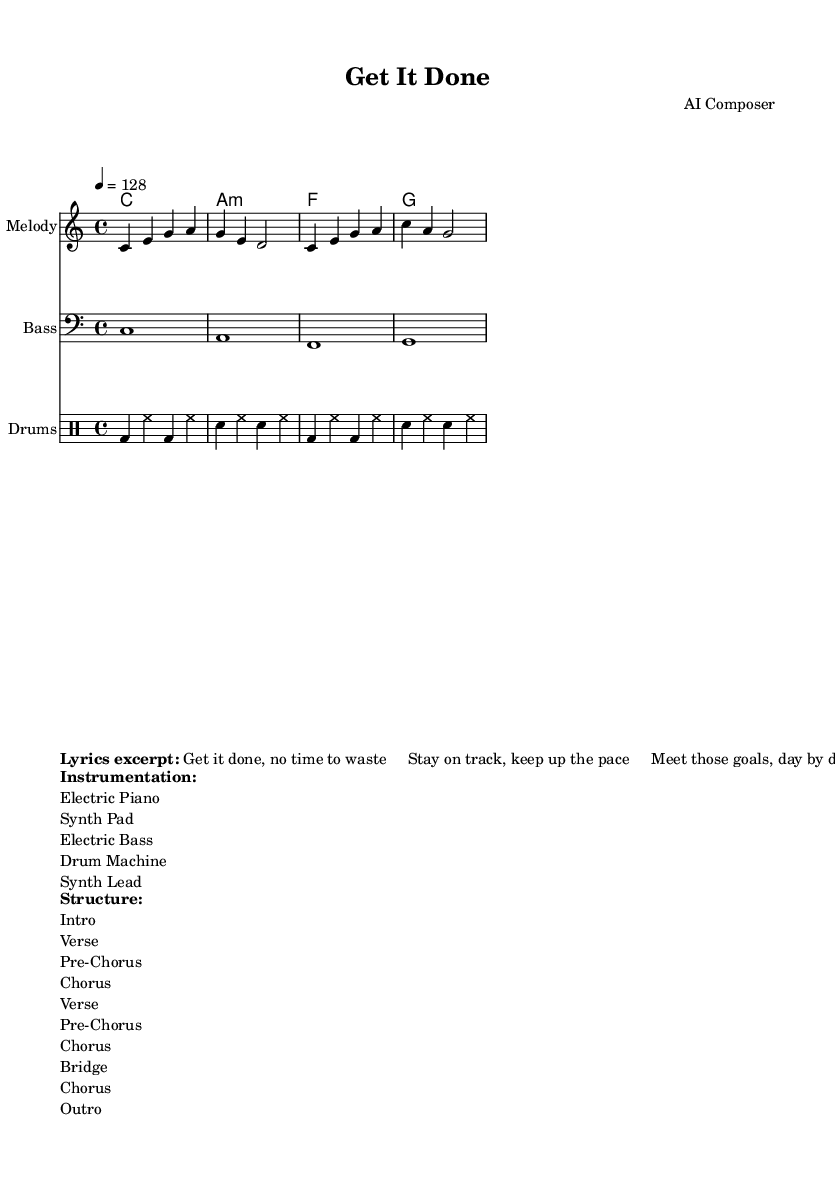What is the key signature of this music? The key signature is C major, which has no sharps or flats.
Answer: C major What is the time signature of this piece? The time signature is indicated as 4/4, meaning four beats per measure.
Answer: 4/4 What is the tempo marking for the song? The tempo marking is set at 128 beats per minute, indicating a moderately fast pace.
Answer: 128 How many sections are there in the structure of the song? The structure includes ten distinct sections: Intro, Verse, Pre-Chorus, Chorus, Verse, Pre-Chorus, Chorus, Bridge, Chorus, and Outro, totaling ten.
Answer: 10 What instruments are used in this composition? The instrumentation listed includes Electric Piano, Synth Pad, Electric Bass, Drum Machine, and Synth Lead, culminating in a rich sound.
Answer: Electric Piano, Synth Pad, Electric Bass, Drum Machine, Synth Lead Which chord is played in the first measure of the Harmony staff? The first measure of the Harmony staff shows a C major chord, which is played for an entire measure.
Answer: C What are the lyrics in the chorus? The excerpt provided features motivational lyrics that emphasize productivity and staying on track, specifically about meeting goals and maintaining pace.
Answer: "Get it done, no time to waste Stay on track, keep up the pace" 